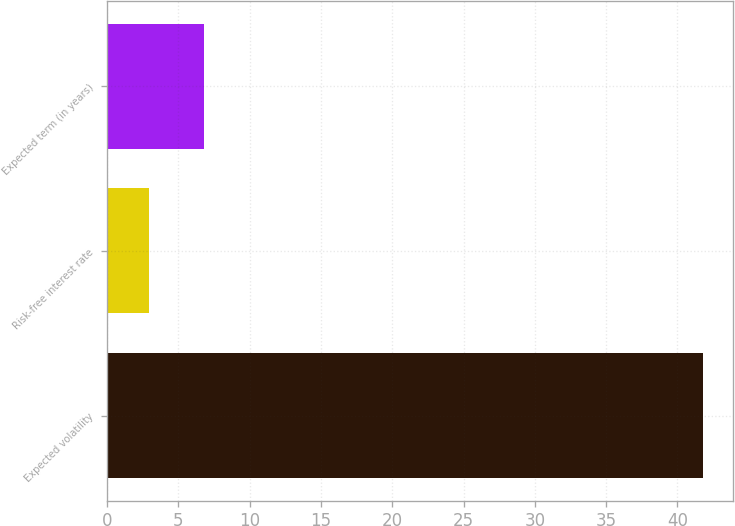<chart> <loc_0><loc_0><loc_500><loc_500><bar_chart><fcel>Expected volatility<fcel>Risk-free interest rate<fcel>Expected term (in years)<nl><fcel>41.8<fcel>2.9<fcel>6.79<nl></chart> 